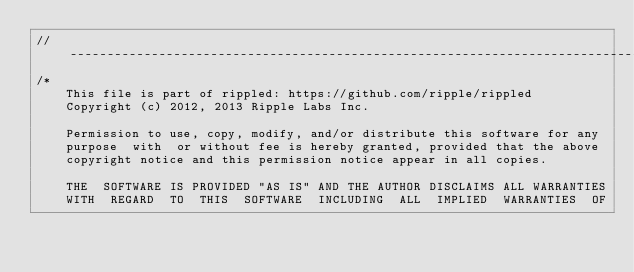<code> <loc_0><loc_0><loc_500><loc_500><_C++_>//------------------------------------------------------------------------------
/*
    This file is part of rippled: https://github.com/ripple/rippled
    Copyright (c) 2012, 2013 Ripple Labs Inc.

    Permission to use, copy, modify, and/or distribute this software for any
    purpose  with  or without fee is hereby granted, provided that the above
    copyright notice and this permission notice appear in all copies.

    THE  SOFTWARE IS PROVIDED "AS IS" AND THE AUTHOR DISCLAIMS ALL WARRANTIES
    WITH  REGARD  TO  THIS  SOFTWARE  INCLUDING  ALL  IMPLIED  WARRANTIES  OF</code> 